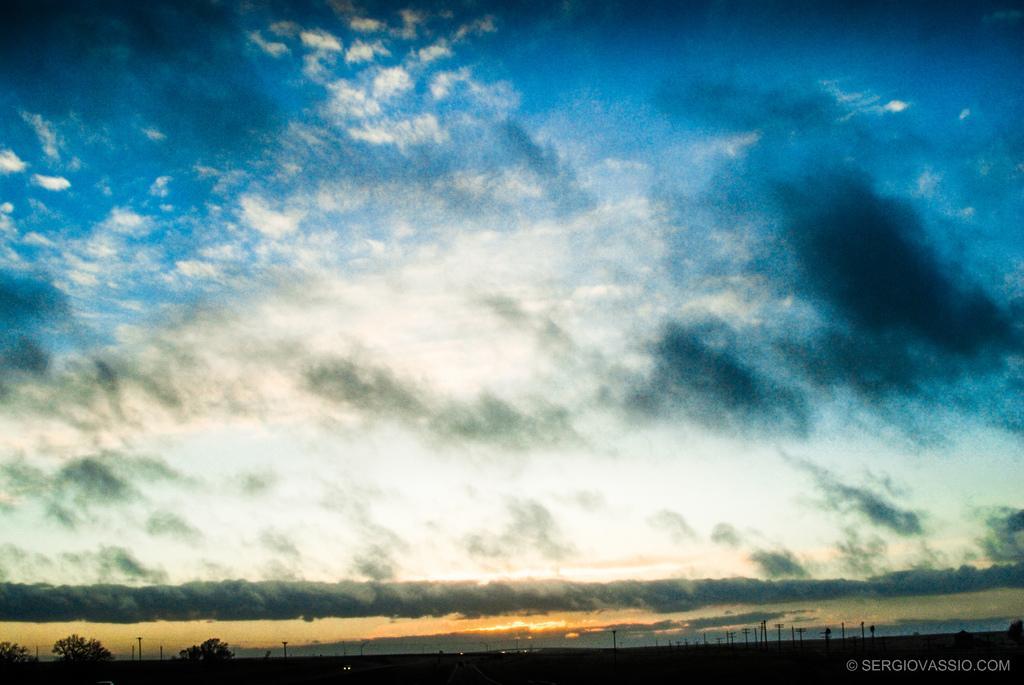How would you summarize this image in a sentence or two? This image is taken outdoors. At the top of the image there is the sky with clouds. At the bottom of the image there are a few trees on the ground and there are a few poles. 